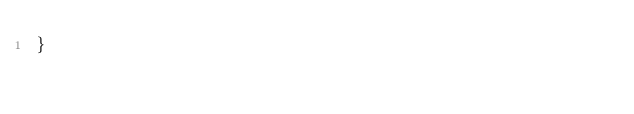<code> <loc_0><loc_0><loc_500><loc_500><_TypeScript_>}
</code> 